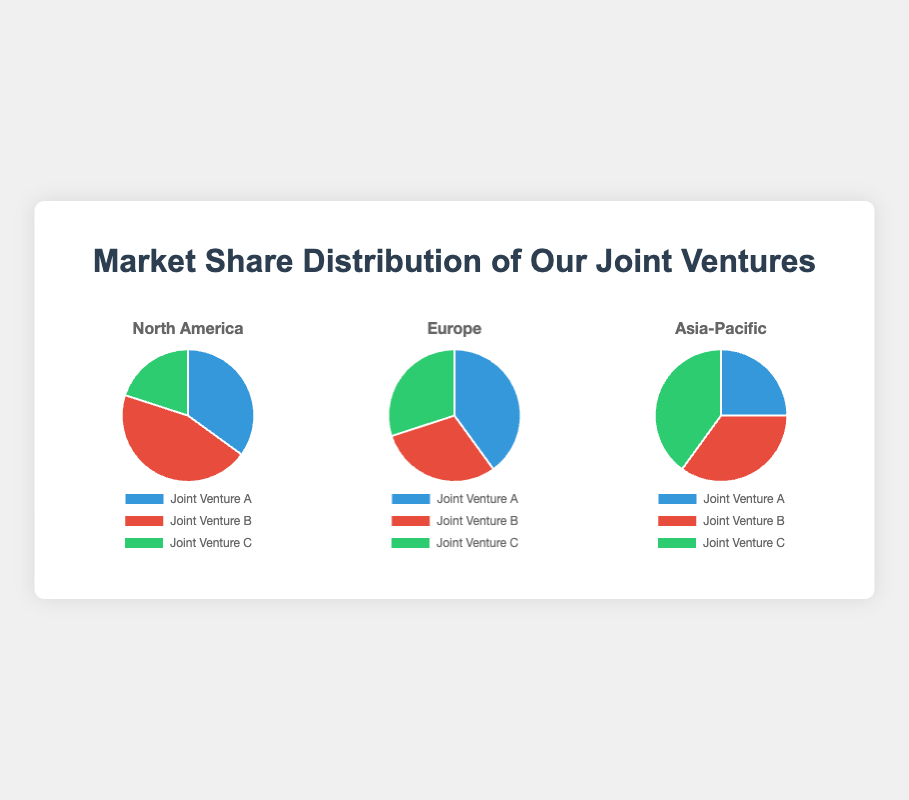Which joint venture has the highest market share in North America? In the pie chart for North America, compare all the sectors. Joint Venture B has the largest share at 45%.
Answer: Joint Venture B What's the difference in market share between Joint Venture A in North America and Joint Venture B in Europe? In North America, Joint Venture A has 35% and in Europe, Joint Venture B has 30%. The difference is 35% - 30% = 5%.
Answer: 5% Which region does Joint Venture C have the largest market share? Compare the pie charts for all regions. Joint Venture C has the largest slice in Asia-Pacific with 40%.
Answer: Asia-Pacific What's the total market share percentage of Joint Ventures B and C in Europe? In the Europe pie chart, Joint Venture B has 30% and Joint Venture C also has 30%. Summing them up gives 30% + 30% = 60%.
Answer: 60% How much higher is Joint Venture A's market share in Europe compared to its market share in Asia-Pacific? In Europe, Joint Venture A has 40% and in Asia-Pacific, it has 25%. The difference is 40% - 25% = 15%.
Answer: 15% Which joint venture has the smallest market share in North America and what percentage is it? In North America, the smallest slice is that of Joint Venture C at 20%.
Answer: Joint Venture C, 20% What is the combined market share of Joint Venture B across all regions? Add up Joint Venture B’s shares: 45% (North America) + 30% (Europe) + 35% (Asia-Pacific) = 110%.
Answer: 110% How does the market share of Joint Venture C in Asia-Pacific compare to that in North America? Joint Venture C has 40% in Asia-Pacific and 20% in North America. 40% is double 20%.
Answer: Double What is the average market share of Joint Venture A across all regions? The shares are 35% (North America), 40% (Europe), 25% (Asia-Pacific). The average is (35% + 40% + 25%) / 3 = 33.33%.
Answer: 33.33% 